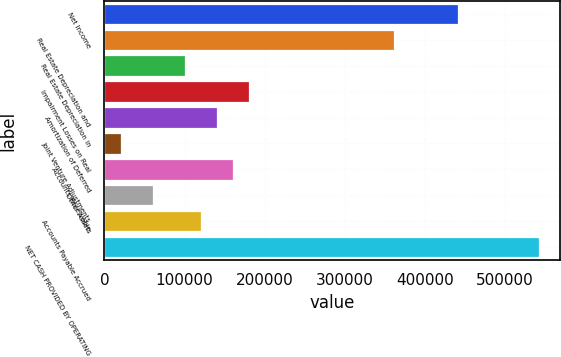Convert chart. <chart><loc_0><loc_0><loc_500><loc_500><bar_chart><fcel>Net Income<fcel>Real Estate Depreciation and<fcel>Real Estate Depreciation in<fcel>Impairment Losses on Real<fcel>Amortization of Deferred<fcel>Joint Venture Adjustments<fcel>Accounts Receivable<fcel>Other Assets<fcel>Accounts Payable Accrued<fcel>NET CASH PROVIDED BY OPERATING<nl><fcel>441590<fcel>361342<fcel>100539<fcel>180786<fcel>140663<fcel>20291.8<fcel>160724<fcel>60415.4<fcel>120601<fcel>541899<nl></chart> 